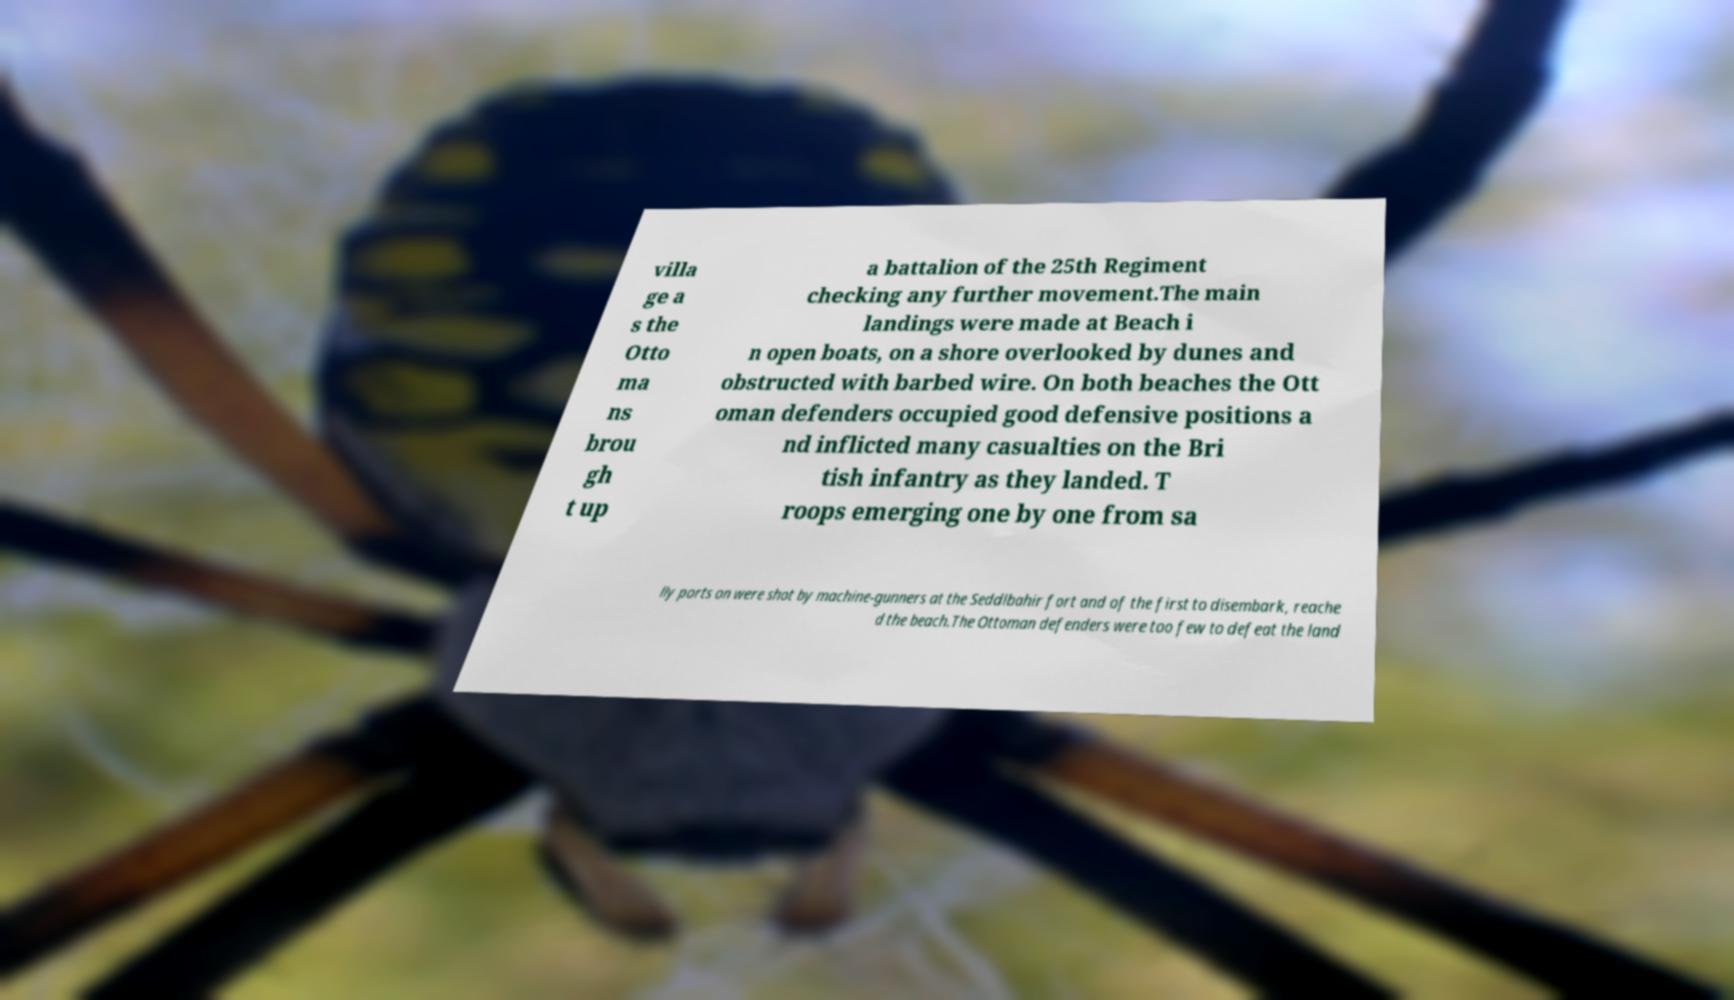Can you read and provide the text displayed in the image?This photo seems to have some interesting text. Can you extract and type it out for me? villa ge a s the Otto ma ns brou gh t up a battalion of the 25th Regiment checking any further movement.The main landings were made at Beach i n open boats, on a shore overlooked by dunes and obstructed with barbed wire. On both beaches the Ott oman defenders occupied good defensive positions a nd inflicted many casualties on the Bri tish infantry as they landed. T roops emerging one by one from sa lly ports on were shot by machine-gunners at the Seddlbahir fort and of the first to disembark, reache d the beach.The Ottoman defenders were too few to defeat the land 